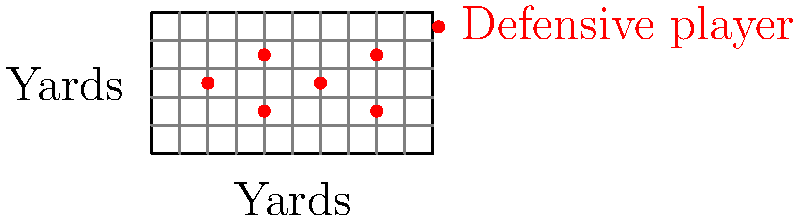Given the defensive formation shown on the football field grid, where each square represents 10 yards, what is the total area (in square yards) of the polygon formed by connecting the outermost defensive players? To solve this problem, we need to follow these steps:

1. Identify the outermost defensive players:
   - Left: (20, 25)
   - Top: (40, 35) and (80, 35)
   - Right: (80, 15) and (80, 35)
   - Bottom: (40, 15) and (80, 15)

2. Form a polygon by connecting these points:
   (20, 25) -> (40, 35) -> (80, 35) -> (80, 15) -> (40, 15) -> (20, 25)

3. Divide this polygon into two triangles and a rectangle:
   - Triangle 1: (20, 25), (40, 35), (40, 25)
   - Rectangle: (40, 15), (40, 35), (80, 35), (80, 15)
   - Triangle 2: (20, 25), (40, 15), (40, 25)

4. Calculate the areas:
   - Triangle 1 area: $\frac{1}{2} \times 20 \times 10 = 100$ sq yards
   - Rectangle area: $40 \times 20 = 800$ sq yards
   - Triangle 2 area: $\frac{1}{2} \times 20 \times 10 = 100$ sq yards

5. Sum up the areas:
   Total area = 100 + 800 + 100 = 1000 sq yards

Therefore, the total area of the polygon formed by the outermost defensive players is 1000 square yards.
Answer: 1000 square yards 